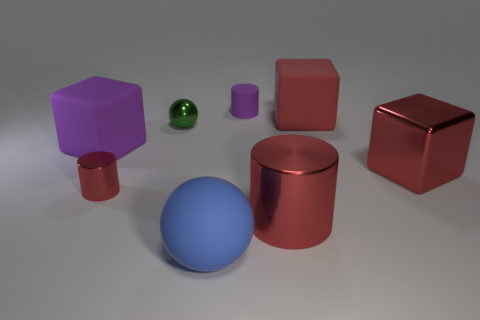What is the color of the cylinder that is the same size as the blue rubber thing? red 